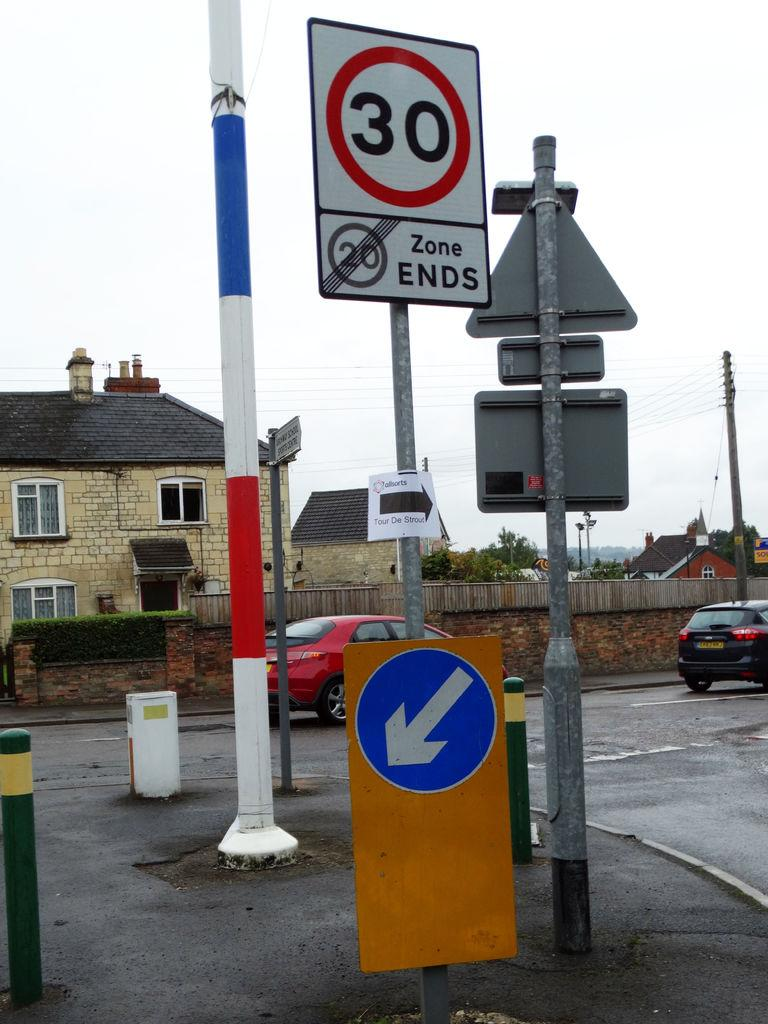<image>
Provide a brief description of the given image. A white street sign says 20 Zone Ends and a red car is in the intersection behind it. 